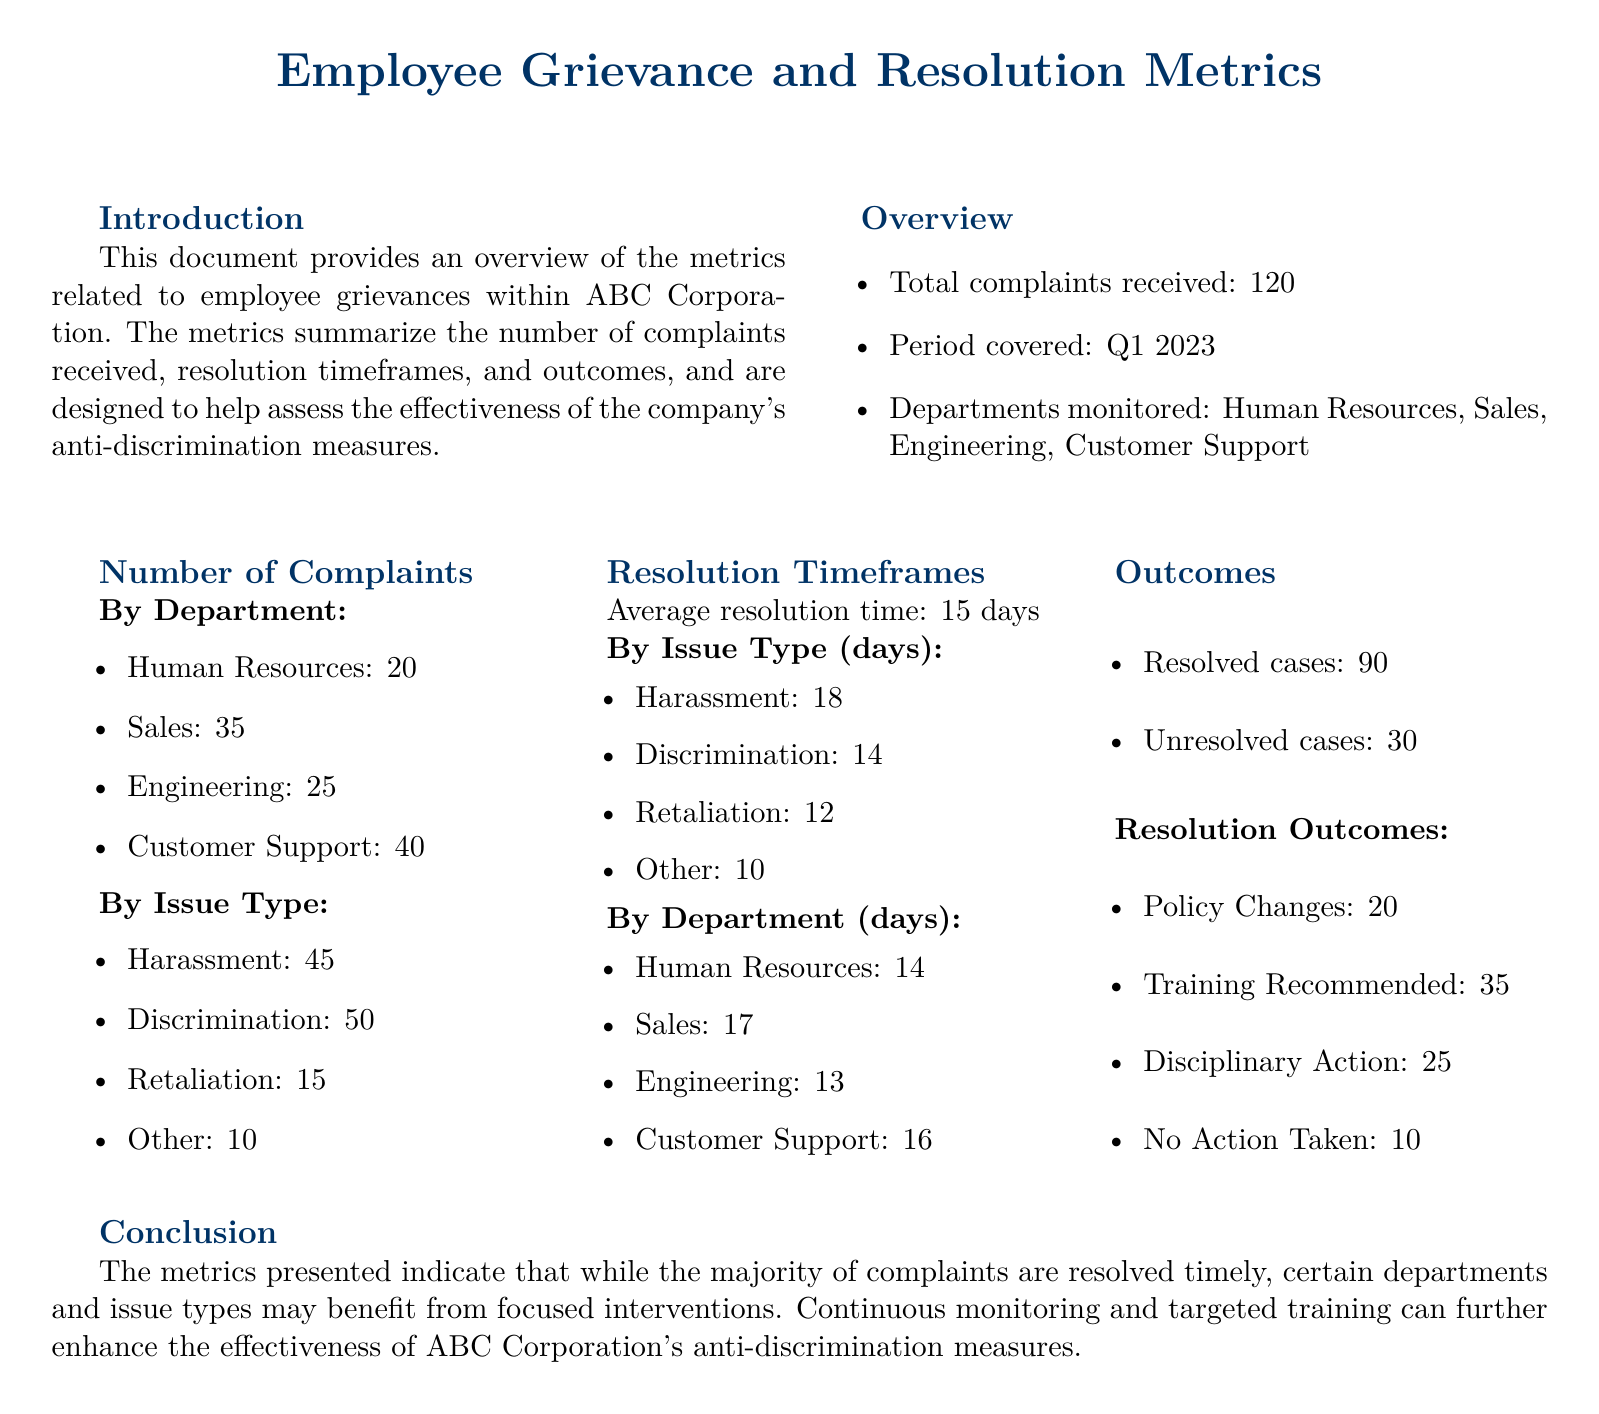what is the total number of complaints received? The total number of complaints received is summarized in the overview section of the document.
Answer: 120 what is the average resolution time for complaints? The average resolution time is mentioned under the resolution timeframes section of the document.
Answer: 15 days how many complaints were filed in the Engineering department? The specific number of complaints in the Engineering department is outlined in the number of complaints by department section.
Answer: 25 what issue type had the highest number of complaints? The issue type with the highest number of complaints can be identified from the number of complaints by issue type section.
Answer: Discrimination how many cases were resolved? The number of resolved cases is detailed in the outcomes section of the document.
Answer: 90 which department had the longest average resolution time? The department with the longest average resolution time is found in the resolution timeframes section.
Answer: Sales how many complaints were categorized as retaliation? The number of complaints categorized as retaliation is listed in the number of complaints by issue type section.
Answer: 15 what percentage of complaints were unresolved? The percentage of unresolved cases can be calculated based on the total complaints and unresolved cases mentioned in the outcomes section.
Answer: 25% what type of resolution had the highest count? The type of resolution with the highest count is found in the resolution outcomes section of the document.
Answer: Training Recommended 